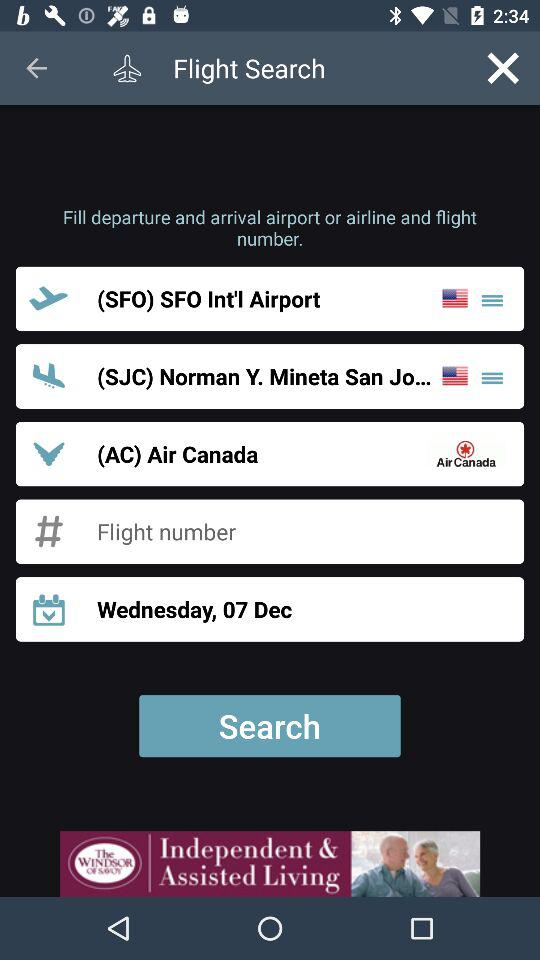What airport is the flight from? The flight is from (SFO) SFO Int'l Airport. 